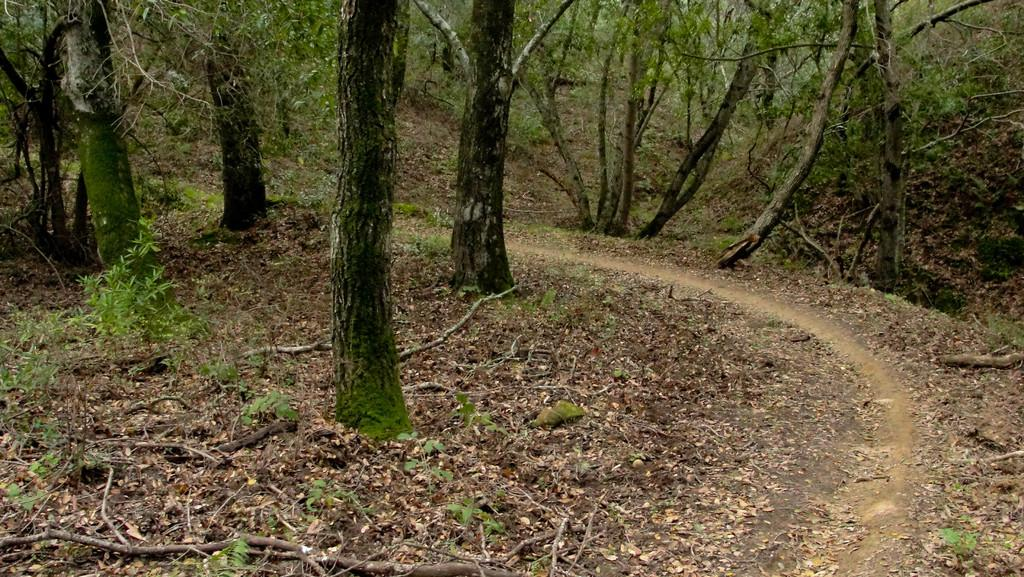Where was the image taken? The image was taken outdoors. What can be seen at the bottom of the image? There is a ground with grass at the bottom of the image. What objects are on the ground in the image? There are sticks and many dry leaves on the ground. What can be seen in the background of the image? There are trees and plants in the background of the image. What type of metal can be seen in the image? There is no metal present in the image. What is the reason for the dry leaves being on the ground in the image? The image does not provide a reason for the dry leaves being on the ground; it simply shows their presence. 